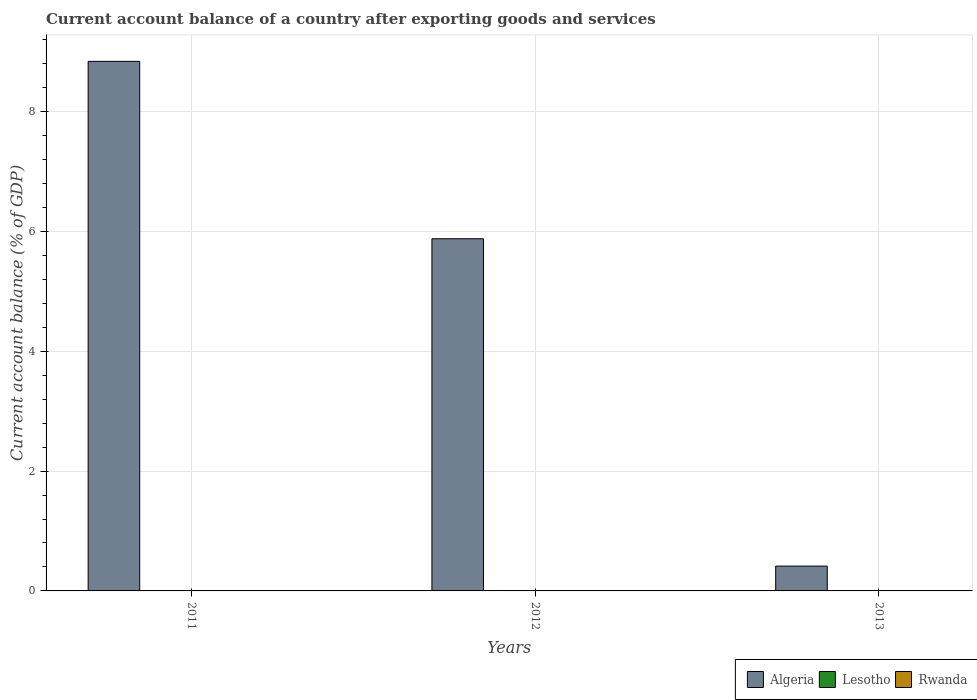Are the number of bars per tick equal to the number of legend labels?
Your answer should be very brief. No. How many bars are there on the 1st tick from the left?
Your answer should be compact. 1. How many bars are there on the 3rd tick from the right?
Offer a very short reply. 1. In how many cases, is the number of bars for a given year not equal to the number of legend labels?
Ensure brevity in your answer.  3. What is the account balance in Algeria in 2012?
Provide a succinct answer. 5.88. Across all years, what is the maximum account balance in Algeria?
Give a very brief answer. 8.84. What is the total account balance in Rwanda in the graph?
Keep it short and to the point. 0. What is the difference between the account balance in Algeria in 2011 and that in 2012?
Offer a very short reply. 2.96. What is the difference between the account balance in Algeria in 2011 and the account balance in Rwanda in 2013?
Your response must be concise. 8.84. What is the average account balance in Algeria per year?
Make the answer very short. 5.04. In how many years, is the account balance in Lesotho greater than 4.8 %?
Give a very brief answer. 0. What is the ratio of the account balance in Algeria in 2011 to that in 2013?
Your answer should be compact. 21.33. What is the difference between the highest and the second highest account balance in Algeria?
Ensure brevity in your answer.  2.96. What is the difference between the highest and the lowest account balance in Algeria?
Keep it short and to the point. 8.43. In how many years, is the account balance in Rwanda greater than the average account balance in Rwanda taken over all years?
Give a very brief answer. 0. Does the graph contain grids?
Offer a terse response. Yes. How many legend labels are there?
Your answer should be very brief. 3. What is the title of the graph?
Provide a succinct answer. Current account balance of a country after exporting goods and services. Does "West Bank and Gaza" appear as one of the legend labels in the graph?
Give a very brief answer. No. What is the label or title of the Y-axis?
Give a very brief answer. Current account balance (% of GDP). What is the Current account balance (% of GDP) in Algeria in 2011?
Provide a short and direct response. 8.84. What is the Current account balance (% of GDP) in Algeria in 2012?
Provide a short and direct response. 5.88. What is the Current account balance (% of GDP) of Lesotho in 2012?
Offer a terse response. 0. What is the Current account balance (% of GDP) in Rwanda in 2012?
Your response must be concise. 0. What is the Current account balance (% of GDP) of Algeria in 2013?
Offer a very short reply. 0.41. What is the Current account balance (% of GDP) of Rwanda in 2013?
Provide a short and direct response. 0. Across all years, what is the maximum Current account balance (% of GDP) in Algeria?
Your answer should be compact. 8.84. Across all years, what is the minimum Current account balance (% of GDP) of Algeria?
Offer a very short reply. 0.41. What is the total Current account balance (% of GDP) of Algeria in the graph?
Give a very brief answer. 15.13. What is the total Current account balance (% of GDP) in Rwanda in the graph?
Offer a very short reply. 0. What is the difference between the Current account balance (% of GDP) of Algeria in 2011 and that in 2012?
Provide a succinct answer. 2.96. What is the difference between the Current account balance (% of GDP) in Algeria in 2011 and that in 2013?
Your answer should be compact. 8.43. What is the difference between the Current account balance (% of GDP) in Algeria in 2012 and that in 2013?
Ensure brevity in your answer.  5.46. What is the average Current account balance (% of GDP) in Algeria per year?
Provide a short and direct response. 5.04. What is the average Current account balance (% of GDP) in Lesotho per year?
Make the answer very short. 0. What is the ratio of the Current account balance (% of GDP) in Algeria in 2011 to that in 2012?
Ensure brevity in your answer.  1.5. What is the ratio of the Current account balance (% of GDP) in Algeria in 2011 to that in 2013?
Provide a short and direct response. 21.33. What is the ratio of the Current account balance (% of GDP) in Algeria in 2012 to that in 2013?
Make the answer very short. 14.18. What is the difference between the highest and the second highest Current account balance (% of GDP) of Algeria?
Keep it short and to the point. 2.96. What is the difference between the highest and the lowest Current account balance (% of GDP) in Algeria?
Your answer should be compact. 8.43. 